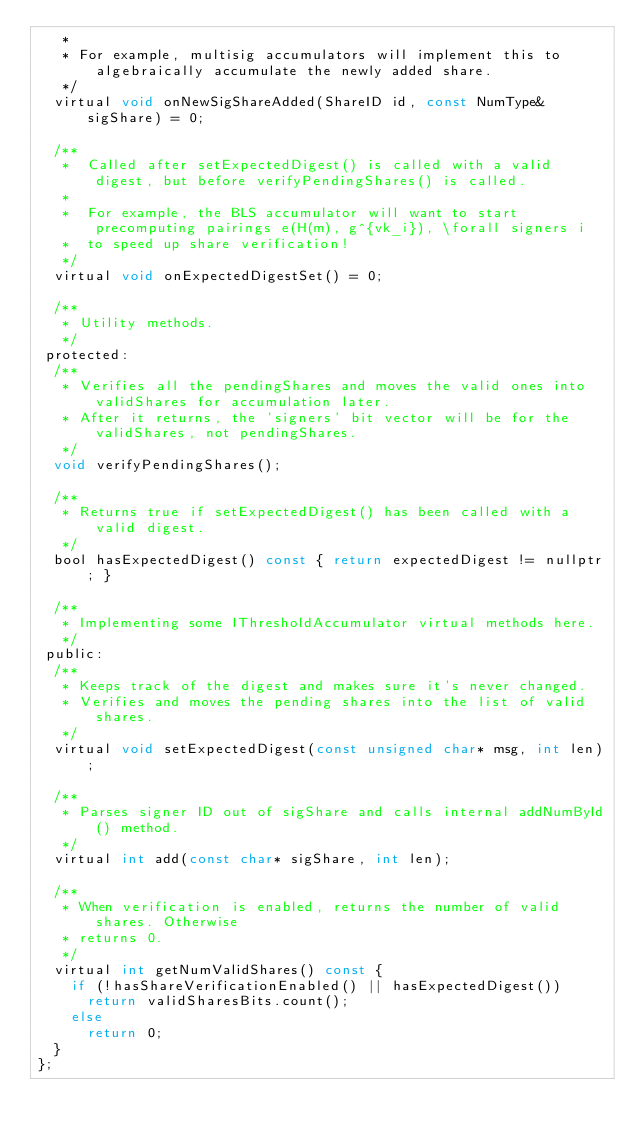<code> <loc_0><loc_0><loc_500><loc_500><_C_>   *
   * For example, multisig accumulators will implement this to algebraically accumulate the newly added share.
   */
  virtual void onNewSigShareAdded(ShareID id, const NumType& sigShare) = 0;

  /**
   * 	Called after setExpectedDigest() is called with a valid digest, but before verifyPendingShares() is called.
   *
   *	For example, the BLS accumulator will want to start precomputing pairings e(H(m), g^{vk_i}), \forall signers i
   *	to speed up share verification!
   */
  virtual void onExpectedDigestSet() = 0;

  /**
   * Utility methods.
   */
 protected:
  /**
   * Verifies all the pendingShares and moves the valid ones into validShares for accumulation later.
   * After it returns, the 'signers' bit vector will be for the validShares, not pendingShares.
   */
  void verifyPendingShares();

  /**
   * Returns true if setExpectedDigest() has been called with a valid digest.
   */
  bool hasExpectedDigest() const { return expectedDigest != nullptr; }

  /**
   * Implementing some IThresholdAccumulator virtual methods here.
   */
 public:
  /**
   * Keeps track of the digest and makes sure it's never changed.
   * Verifies and moves the pending shares into the list of valid shares.
   */
  virtual void setExpectedDigest(const unsigned char* msg, int len);

  /**
   * Parses signer ID out of sigShare and calls internal addNumById() method.
   */
  virtual int add(const char* sigShare, int len);

  /**
   * When verification is enabled, returns the number of valid shares. Otherwise
   * returns 0.
   */
  virtual int getNumValidShares() const {
    if (!hasShareVerificationEnabled() || hasExpectedDigest())
      return validSharesBits.count();
    else
      return 0;
  }
};
</code> 